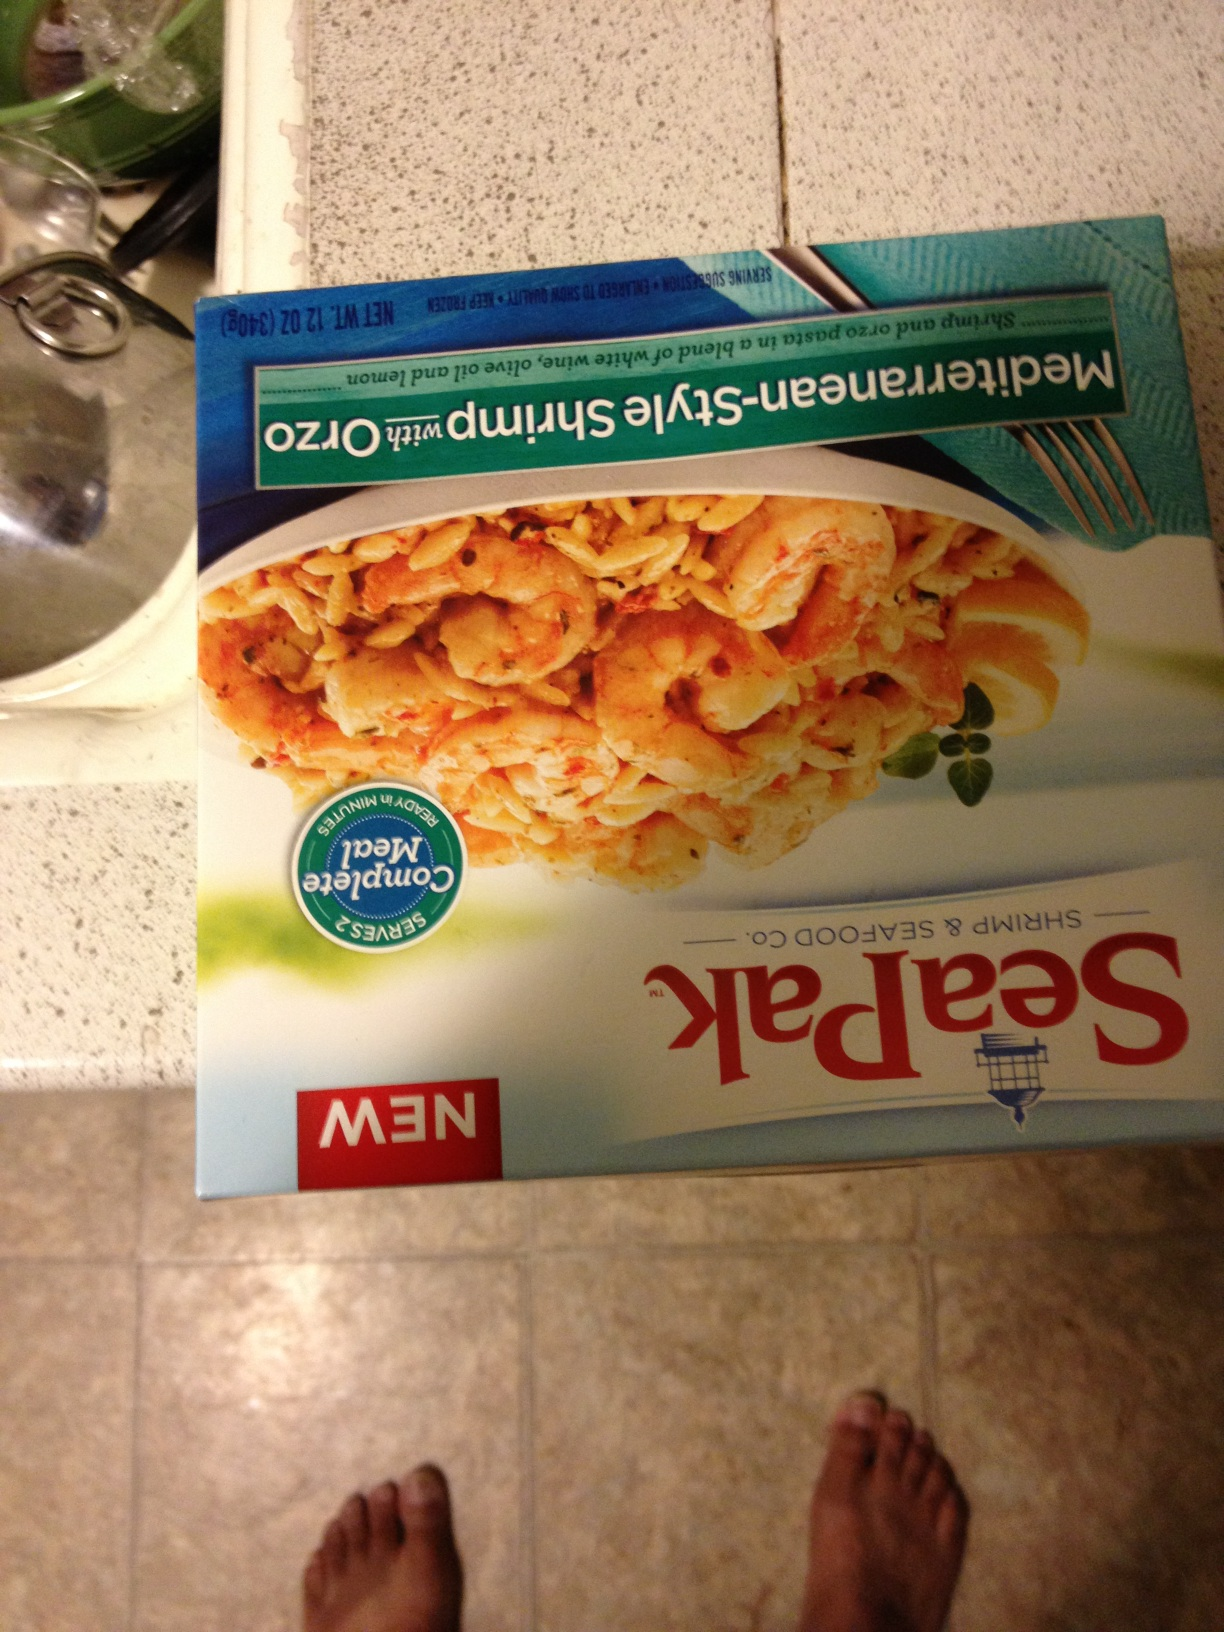What cuisine influences are shown in this shrimp dish on the packaging? The shrimp dish on the packaging is influenced by Mediterranean cuisine, characterized by the use of herbs and spices typical to the Mediterranean region such as garlic, basil, and oregano. 